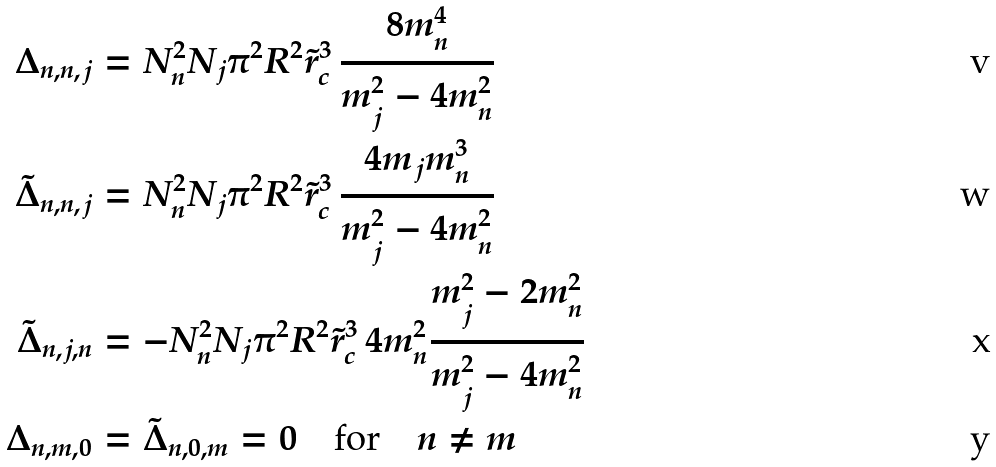Convert formula to latex. <formula><loc_0><loc_0><loc_500><loc_500>\Delta _ { n , n , j } & = N _ { n } ^ { 2 } N _ { j } \pi ^ { 2 } R ^ { 2 } \tilde { r } _ { c } ^ { 3 } \, \frac { 8 m _ { n } ^ { 4 } } { m _ { j } ^ { 2 } - 4 m _ { n } ^ { 2 } } \\ \tilde { \Delta } _ { n , n , j } & = N _ { n } ^ { 2 } N _ { j } \pi ^ { 2 } R ^ { 2 } \tilde { r } _ { c } ^ { 3 } \, \frac { 4 m _ { j } m _ { n } ^ { 3 } } { m _ { j } ^ { 2 } - 4 m _ { n } ^ { 2 } } \\ \tilde { \Delta } _ { n , j , n } & = - N _ { n } ^ { 2 } N _ { j } \pi ^ { 2 } R ^ { 2 } \tilde { r } _ { c } ^ { 3 } \, 4 m _ { n } ^ { 2 } \frac { m _ { j } ^ { 2 } - 2 m _ { n } ^ { 2 } } { m _ { j } ^ { 2 } - 4 m _ { n } ^ { 2 } } \\ \Delta _ { n , m , 0 } & = \tilde { \Delta } _ { n , 0 , m } = 0 \quad \text {for} \quad n \neq m</formula> 